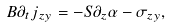<formula> <loc_0><loc_0><loc_500><loc_500>B \partial _ { t } j _ { z y } = - S \partial _ { z } \alpha - \sigma _ { z y } ,</formula> 